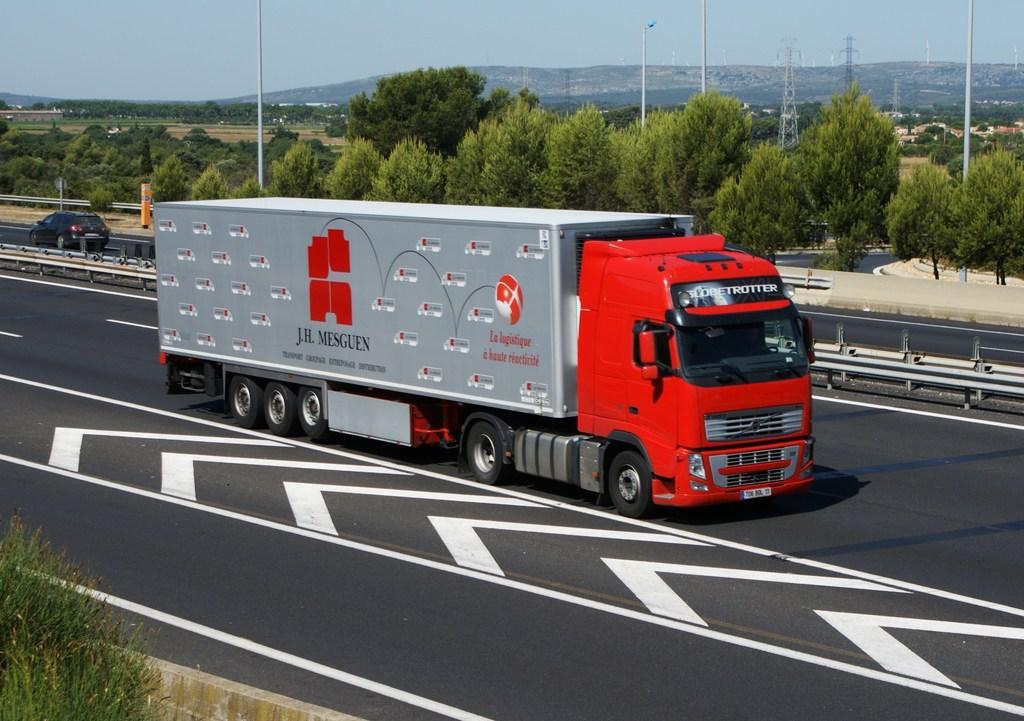In one or two sentences, can you explain what this image depicts? In this image I can see few vehicles on the road. I can see few trees, poles, towers, mountains and the sky. 